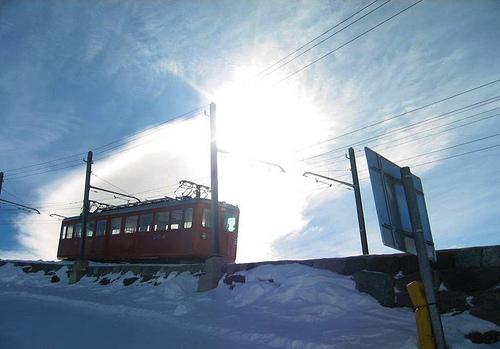Is cold in this picture?
Short answer required. Yes. Is the sun peeking through the clouds?
Concise answer only. Yes. Could this be a train engine?
Write a very short answer. No. Is this an indoor area?
Short answer required. No. Is tram working or stop because of snow?
Give a very brief answer. Working. Is there a sign?
Write a very short answer. Yes. Is this photo digital?
Keep it brief. Yes. 